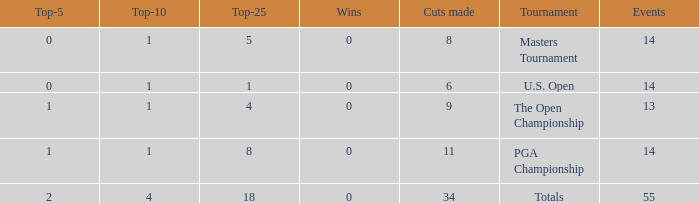What is the average top-10 when the cuts made is less than 9 and the events is more than 14? None. 